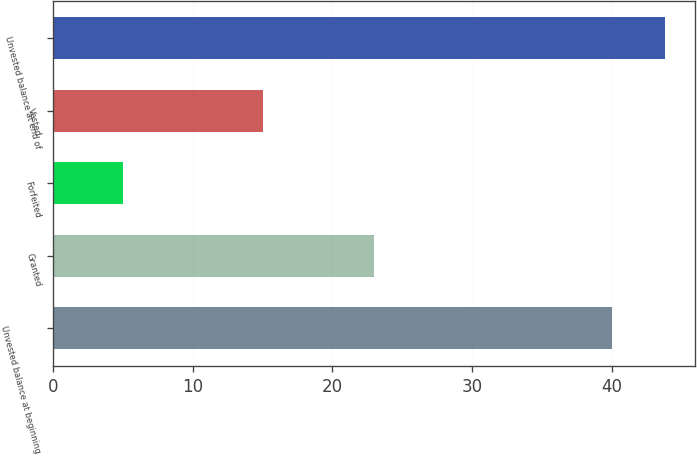Convert chart to OTSL. <chart><loc_0><loc_0><loc_500><loc_500><bar_chart><fcel>Unvested balance at beginning<fcel>Granted<fcel>Forfeited<fcel>Vested<fcel>Unvested balance at end of<nl><fcel>40<fcel>23<fcel>5<fcel>15<fcel>43.8<nl></chart> 